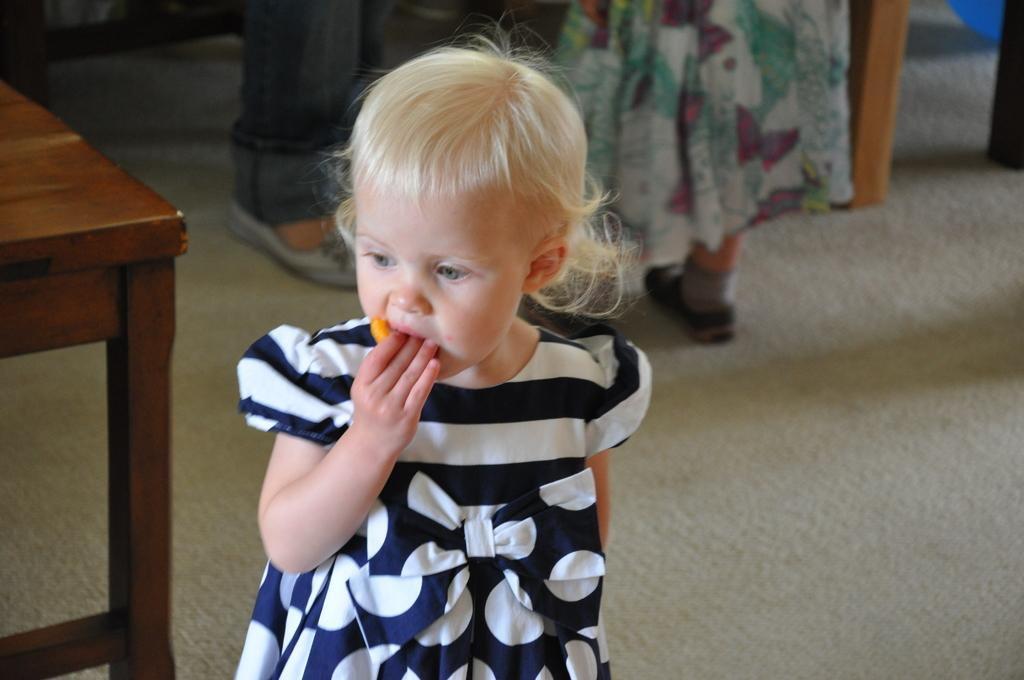Who is present in the image? There are children in the image. What are the children doing in the image? The children are standing on the floor. What other object can be seen in the image? There is a table in the image. What type of chalk is the judge using to write on the paper in the image? There is no judge, chalk, or paper present in the image. 